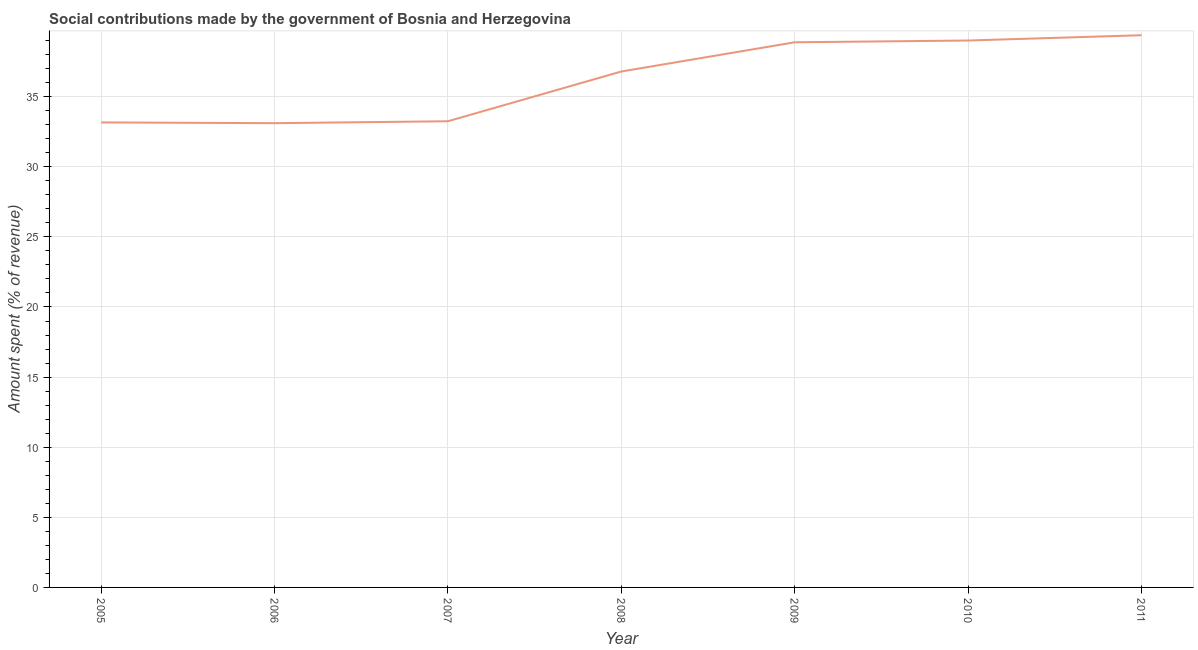What is the amount spent in making social contributions in 2007?
Give a very brief answer. 33.25. Across all years, what is the maximum amount spent in making social contributions?
Provide a succinct answer. 39.38. Across all years, what is the minimum amount spent in making social contributions?
Give a very brief answer. 33.11. In which year was the amount spent in making social contributions maximum?
Keep it short and to the point. 2011. In which year was the amount spent in making social contributions minimum?
Make the answer very short. 2006. What is the sum of the amount spent in making social contributions?
Your answer should be compact. 253.57. What is the difference between the amount spent in making social contributions in 2005 and 2007?
Provide a succinct answer. -0.08. What is the average amount spent in making social contributions per year?
Provide a short and direct response. 36.22. What is the median amount spent in making social contributions?
Your answer should be very brief. 36.79. What is the ratio of the amount spent in making social contributions in 2008 to that in 2010?
Your answer should be very brief. 0.94. What is the difference between the highest and the second highest amount spent in making social contributions?
Give a very brief answer. 0.38. Is the sum of the amount spent in making social contributions in 2007 and 2008 greater than the maximum amount spent in making social contributions across all years?
Ensure brevity in your answer.  Yes. What is the difference between the highest and the lowest amount spent in making social contributions?
Your answer should be very brief. 6.27. How many lines are there?
Provide a short and direct response. 1. What is the difference between two consecutive major ticks on the Y-axis?
Your answer should be very brief. 5. Does the graph contain grids?
Your answer should be very brief. Yes. What is the title of the graph?
Your response must be concise. Social contributions made by the government of Bosnia and Herzegovina. What is the label or title of the Y-axis?
Offer a very short reply. Amount spent (% of revenue). What is the Amount spent (% of revenue) in 2005?
Ensure brevity in your answer.  33.16. What is the Amount spent (% of revenue) in 2006?
Your response must be concise. 33.11. What is the Amount spent (% of revenue) of 2007?
Your response must be concise. 33.25. What is the Amount spent (% of revenue) in 2008?
Provide a succinct answer. 36.79. What is the Amount spent (% of revenue) in 2009?
Your answer should be very brief. 38.88. What is the Amount spent (% of revenue) in 2010?
Provide a succinct answer. 39. What is the Amount spent (% of revenue) in 2011?
Ensure brevity in your answer.  39.38. What is the difference between the Amount spent (% of revenue) in 2005 and 2006?
Your answer should be compact. 0.05. What is the difference between the Amount spent (% of revenue) in 2005 and 2007?
Ensure brevity in your answer.  -0.08. What is the difference between the Amount spent (% of revenue) in 2005 and 2008?
Give a very brief answer. -3.63. What is the difference between the Amount spent (% of revenue) in 2005 and 2009?
Give a very brief answer. -5.71. What is the difference between the Amount spent (% of revenue) in 2005 and 2010?
Your answer should be very brief. -5.84. What is the difference between the Amount spent (% of revenue) in 2005 and 2011?
Your answer should be compact. -6.22. What is the difference between the Amount spent (% of revenue) in 2006 and 2007?
Keep it short and to the point. -0.14. What is the difference between the Amount spent (% of revenue) in 2006 and 2008?
Your answer should be very brief. -3.69. What is the difference between the Amount spent (% of revenue) in 2006 and 2009?
Keep it short and to the point. -5.77. What is the difference between the Amount spent (% of revenue) in 2006 and 2010?
Ensure brevity in your answer.  -5.89. What is the difference between the Amount spent (% of revenue) in 2006 and 2011?
Keep it short and to the point. -6.27. What is the difference between the Amount spent (% of revenue) in 2007 and 2008?
Provide a short and direct response. -3.55. What is the difference between the Amount spent (% of revenue) in 2007 and 2009?
Make the answer very short. -5.63. What is the difference between the Amount spent (% of revenue) in 2007 and 2010?
Keep it short and to the point. -5.76. What is the difference between the Amount spent (% of revenue) in 2007 and 2011?
Your answer should be compact. -6.13. What is the difference between the Amount spent (% of revenue) in 2008 and 2009?
Keep it short and to the point. -2.08. What is the difference between the Amount spent (% of revenue) in 2008 and 2010?
Your answer should be very brief. -2.21. What is the difference between the Amount spent (% of revenue) in 2008 and 2011?
Provide a short and direct response. -2.59. What is the difference between the Amount spent (% of revenue) in 2009 and 2010?
Offer a very short reply. -0.13. What is the difference between the Amount spent (% of revenue) in 2009 and 2011?
Give a very brief answer. -0.5. What is the difference between the Amount spent (% of revenue) in 2010 and 2011?
Ensure brevity in your answer.  -0.38. What is the ratio of the Amount spent (% of revenue) in 2005 to that in 2006?
Your answer should be very brief. 1. What is the ratio of the Amount spent (% of revenue) in 2005 to that in 2008?
Make the answer very short. 0.9. What is the ratio of the Amount spent (% of revenue) in 2005 to that in 2009?
Provide a succinct answer. 0.85. What is the ratio of the Amount spent (% of revenue) in 2005 to that in 2011?
Provide a short and direct response. 0.84. What is the ratio of the Amount spent (% of revenue) in 2006 to that in 2007?
Provide a short and direct response. 1. What is the ratio of the Amount spent (% of revenue) in 2006 to that in 2008?
Provide a short and direct response. 0.9. What is the ratio of the Amount spent (% of revenue) in 2006 to that in 2009?
Ensure brevity in your answer.  0.85. What is the ratio of the Amount spent (% of revenue) in 2006 to that in 2010?
Provide a succinct answer. 0.85. What is the ratio of the Amount spent (% of revenue) in 2006 to that in 2011?
Provide a succinct answer. 0.84. What is the ratio of the Amount spent (% of revenue) in 2007 to that in 2008?
Make the answer very short. 0.9. What is the ratio of the Amount spent (% of revenue) in 2007 to that in 2009?
Ensure brevity in your answer.  0.85. What is the ratio of the Amount spent (% of revenue) in 2007 to that in 2010?
Give a very brief answer. 0.85. What is the ratio of the Amount spent (% of revenue) in 2007 to that in 2011?
Provide a succinct answer. 0.84. What is the ratio of the Amount spent (% of revenue) in 2008 to that in 2009?
Provide a succinct answer. 0.95. What is the ratio of the Amount spent (% of revenue) in 2008 to that in 2010?
Provide a short and direct response. 0.94. What is the ratio of the Amount spent (% of revenue) in 2008 to that in 2011?
Your answer should be compact. 0.93. What is the ratio of the Amount spent (% of revenue) in 2009 to that in 2011?
Provide a short and direct response. 0.99. What is the ratio of the Amount spent (% of revenue) in 2010 to that in 2011?
Provide a short and direct response. 0.99. 